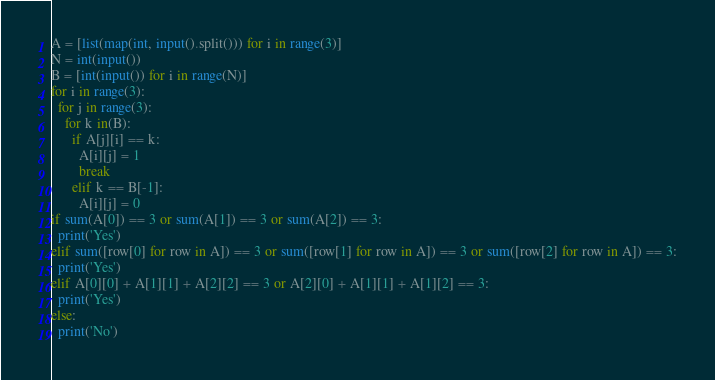<code> <loc_0><loc_0><loc_500><loc_500><_Python_>A = [list(map(int, input().split())) for i in range(3)]
N = int(input())
B = [int(input()) for i in range(N)]
for i in range(3):
  for j in range(3):
    for k in(B):
      if A[j][i] == k:
        A[i][j] = 1
        break
      elif k == B[-1]:
        A[i][j] = 0
if sum(A[0]) == 3 or sum(A[1]) == 3 or sum(A[2]) == 3:
  print('Yes')
elif sum([row[0] for row in A]) == 3 or sum([row[1] for row in A]) == 3 or sum([row[2] for row in A]) == 3:
  print('Yes')
elif A[0][0] + A[1][1] + A[2][2] == 3 or A[2][0] + A[1][1] + A[1][2] == 3:
  print('Yes')
else:
  print('No')</code> 